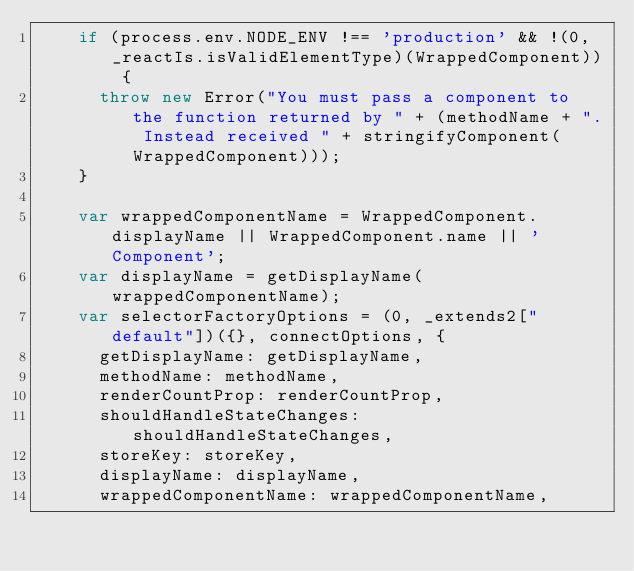<code> <loc_0><loc_0><loc_500><loc_500><_JavaScript_>    if (process.env.NODE_ENV !== 'production' && !(0, _reactIs.isValidElementType)(WrappedComponent)) {
      throw new Error("You must pass a component to the function returned by " + (methodName + ". Instead received " + stringifyComponent(WrappedComponent)));
    }

    var wrappedComponentName = WrappedComponent.displayName || WrappedComponent.name || 'Component';
    var displayName = getDisplayName(wrappedComponentName);
    var selectorFactoryOptions = (0, _extends2["default"])({}, connectOptions, {
      getDisplayName: getDisplayName,
      methodName: methodName,
      renderCountProp: renderCountProp,
      shouldHandleStateChanges: shouldHandleStateChanges,
      storeKey: storeKey,
      displayName: displayName,
      wrappedComponentName: wrappedComponentName,</code> 